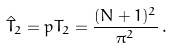<formula> <loc_0><loc_0><loc_500><loc_500>\hat { T } _ { 2 } = p T _ { 2 } = \frac { ( N + 1 ) ^ { 2 } } { \pi ^ { 2 } } \, .</formula> 